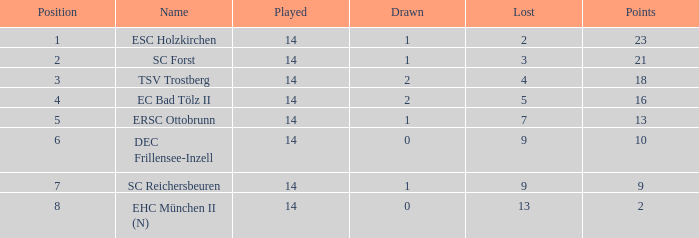Which Points is the highest one that has a Drawn smaller than 2, and a Name of esc holzkirchen, and Played smaller than 14? None. 